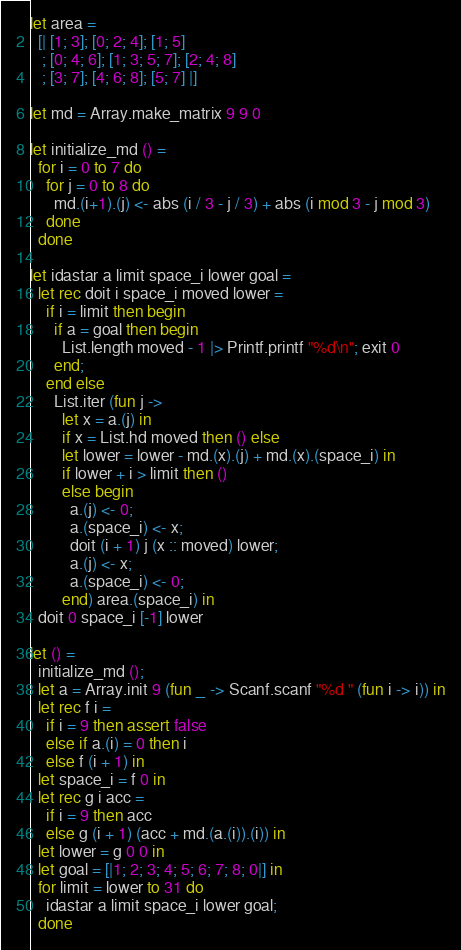<code> <loc_0><loc_0><loc_500><loc_500><_OCaml_>let area =
  [| [1; 3]; [0; 2; 4]; [1; 5]
   ; [0; 4; 6]; [1; 3; 5; 7]; [2; 4; 8]
   ; [3; 7]; [4; 6; 8]; [5; 7] |]

let md = Array.make_matrix 9 9 0

let initialize_md () =
  for i = 0 to 7 do
    for j = 0 to 8 do
      md.(i+1).(j) <- abs (i / 3 - j / 3) + abs (i mod 3 - j mod 3)
    done
  done

let idastar a limit space_i lower goal =
  let rec doit i space_i moved lower =
    if i = limit then begin
      if a = goal then begin
        List.length moved - 1 |> Printf.printf "%d\n"; exit 0
      end;
    end else
      List.iter (fun j ->
        let x = a.(j) in
        if x = List.hd moved then () else
        let lower = lower - md.(x).(j) + md.(x).(space_i) in
        if lower + i > limit then ()
        else begin
          a.(j) <- 0;
          a.(space_i) <- x;
          doit (i + 1) j (x :: moved) lower;
          a.(j) <- x;
          a.(space_i) <- 0;
        end) area.(space_i) in
  doit 0 space_i [-1] lower

let () =
  initialize_md ();
  let a = Array.init 9 (fun _ -> Scanf.scanf "%d " (fun i -> i)) in
  let rec f i =
    if i = 9 then assert false
    else if a.(i) = 0 then i
    else f (i + 1) in
  let space_i = f 0 in
  let rec g i acc =
    if i = 9 then acc
    else g (i + 1) (acc + md.(a.(i)).(i)) in
  let lower = g 0 0 in
  let goal = [|1; 2; 3; 4; 5; 6; 7; 8; 0|] in
  for limit = lower to 31 do
    idastar a limit space_i lower goal;
  done</code> 